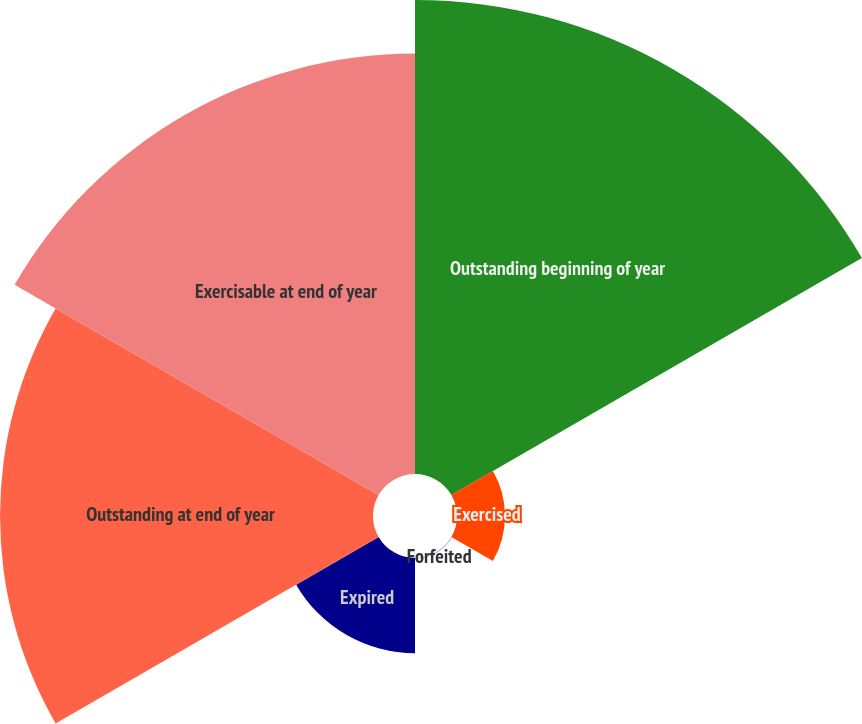Convert chart. <chart><loc_0><loc_0><loc_500><loc_500><pie_chart><fcel>Outstanding beginning of year<fcel>Exercised<fcel>Forfeited<fcel>Expired<fcel>Outstanding at end of year<fcel>Exercisable at end of year<nl><fcel>33.59%<fcel>3.4%<fcel>0.04%<fcel>6.75%<fcel>26.43%<fcel>29.79%<nl></chart> 